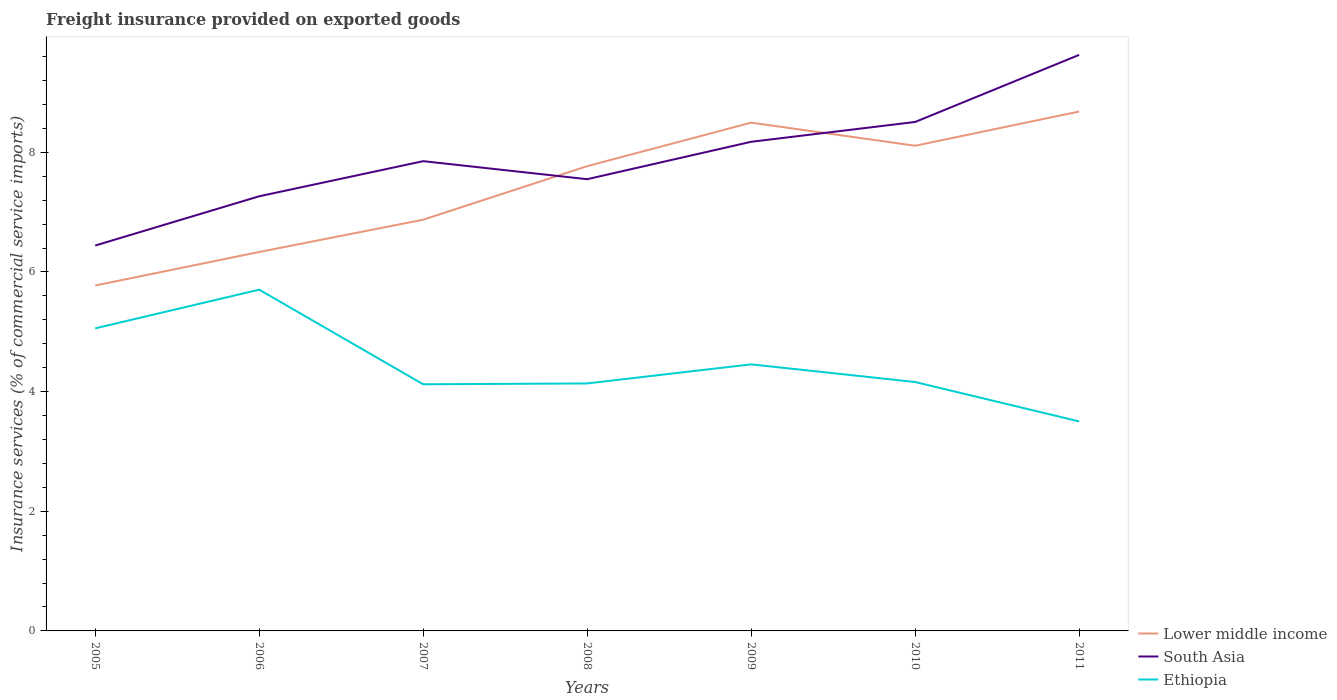How many different coloured lines are there?
Offer a very short reply. 3. Across all years, what is the maximum freight insurance provided on exported goods in South Asia?
Offer a terse response. 6.44. In which year was the freight insurance provided on exported goods in South Asia maximum?
Offer a terse response. 2005. What is the total freight insurance provided on exported goods in South Asia in the graph?
Your answer should be compact. 0.3. What is the difference between the highest and the second highest freight insurance provided on exported goods in South Asia?
Make the answer very short. 3.19. What is the difference between the highest and the lowest freight insurance provided on exported goods in South Asia?
Your answer should be compact. 3. Is the freight insurance provided on exported goods in Ethiopia strictly greater than the freight insurance provided on exported goods in Lower middle income over the years?
Your answer should be compact. Yes. How many years are there in the graph?
Your response must be concise. 7. What is the difference between two consecutive major ticks on the Y-axis?
Offer a terse response. 2. Are the values on the major ticks of Y-axis written in scientific E-notation?
Your response must be concise. No. Does the graph contain any zero values?
Your response must be concise. No. Where does the legend appear in the graph?
Your answer should be very brief. Bottom right. How are the legend labels stacked?
Provide a succinct answer. Vertical. What is the title of the graph?
Your response must be concise. Freight insurance provided on exported goods. What is the label or title of the Y-axis?
Make the answer very short. Insurance services (% of commercial service imports). What is the Insurance services (% of commercial service imports) of Lower middle income in 2005?
Your answer should be compact. 5.77. What is the Insurance services (% of commercial service imports) of South Asia in 2005?
Your answer should be very brief. 6.44. What is the Insurance services (% of commercial service imports) of Ethiopia in 2005?
Offer a very short reply. 5.06. What is the Insurance services (% of commercial service imports) in Lower middle income in 2006?
Your response must be concise. 6.33. What is the Insurance services (% of commercial service imports) in South Asia in 2006?
Offer a very short reply. 7.27. What is the Insurance services (% of commercial service imports) in Ethiopia in 2006?
Offer a terse response. 5.7. What is the Insurance services (% of commercial service imports) of Lower middle income in 2007?
Offer a very short reply. 6.87. What is the Insurance services (% of commercial service imports) in South Asia in 2007?
Your answer should be compact. 7.85. What is the Insurance services (% of commercial service imports) in Ethiopia in 2007?
Keep it short and to the point. 4.12. What is the Insurance services (% of commercial service imports) of Lower middle income in 2008?
Your answer should be compact. 7.77. What is the Insurance services (% of commercial service imports) in South Asia in 2008?
Ensure brevity in your answer.  7.55. What is the Insurance services (% of commercial service imports) in Ethiopia in 2008?
Provide a short and direct response. 4.14. What is the Insurance services (% of commercial service imports) of Lower middle income in 2009?
Offer a terse response. 8.5. What is the Insurance services (% of commercial service imports) in South Asia in 2009?
Keep it short and to the point. 8.18. What is the Insurance services (% of commercial service imports) of Ethiopia in 2009?
Your answer should be very brief. 4.46. What is the Insurance services (% of commercial service imports) of Lower middle income in 2010?
Your answer should be very brief. 8.11. What is the Insurance services (% of commercial service imports) in South Asia in 2010?
Offer a terse response. 8.51. What is the Insurance services (% of commercial service imports) of Ethiopia in 2010?
Provide a short and direct response. 4.16. What is the Insurance services (% of commercial service imports) in Lower middle income in 2011?
Provide a succinct answer. 8.68. What is the Insurance services (% of commercial service imports) in South Asia in 2011?
Make the answer very short. 9.63. What is the Insurance services (% of commercial service imports) of Ethiopia in 2011?
Your answer should be very brief. 3.5. Across all years, what is the maximum Insurance services (% of commercial service imports) of Lower middle income?
Keep it short and to the point. 8.68. Across all years, what is the maximum Insurance services (% of commercial service imports) of South Asia?
Your answer should be very brief. 9.63. Across all years, what is the maximum Insurance services (% of commercial service imports) in Ethiopia?
Make the answer very short. 5.7. Across all years, what is the minimum Insurance services (% of commercial service imports) of Lower middle income?
Offer a terse response. 5.77. Across all years, what is the minimum Insurance services (% of commercial service imports) in South Asia?
Your answer should be very brief. 6.44. Across all years, what is the minimum Insurance services (% of commercial service imports) in Ethiopia?
Provide a succinct answer. 3.5. What is the total Insurance services (% of commercial service imports) of Lower middle income in the graph?
Ensure brevity in your answer.  52.04. What is the total Insurance services (% of commercial service imports) in South Asia in the graph?
Provide a succinct answer. 55.42. What is the total Insurance services (% of commercial service imports) in Ethiopia in the graph?
Make the answer very short. 31.14. What is the difference between the Insurance services (% of commercial service imports) of Lower middle income in 2005 and that in 2006?
Offer a very short reply. -0.56. What is the difference between the Insurance services (% of commercial service imports) of South Asia in 2005 and that in 2006?
Give a very brief answer. -0.82. What is the difference between the Insurance services (% of commercial service imports) of Ethiopia in 2005 and that in 2006?
Offer a very short reply. -0.65. What is the difference between the Insurance services (% of commercial service imports) of Lower middle income in 2005 and that in 2007?
Keep it short and to the point. -1.1. What is the difference between the Insurance services (% of commercial service imports) in South Asia in 2005 and that in 2007?
Make the answer very short. -1.41. What is the difference between the Insurance services (% of commercial service imports) in Ethiopia in 2005 and that in 2007?
Offer a very short reply. 0.94. What is the difference between the Insurance services (% of commercial service imports) of Lower middle income in 2005 and that in 2008?
Keep it short and to the point. -2. What is the difference between the Insurance services (% of commercial service imports) of South Asia in 2005 and that in 2008?
Your answer should be very brief. -1.11. What is the difference between the Insurance services (% of commercial service imports) in Ethiopia in 2005 and that in 2008?
Provide a succinct answer. 0.92. What is the difference between the Insurance services (% of commercial service imports) of Lower middle income in 2005 and that in 2009?
Offer a very short reply. -2.72. What is the difference between the Insurance services (% of commercial service imports) in South Asia in 2005 and that in 2009?
Offer a very short reply. -1.73. What is the difference between the Insurance services (% of commercial service imports) of Ethiopia in 2005 and that in 2009?
Provide a short and direct response. 0.6. What is the difference between the Insurance services (% of commercial service imports) of Lower middle income in 2005 and that in 2010?
Ensure brevity in your answer.  -2.34. What is the difference between the Insurance services (% of commercial service imports) of South Asia in 2005 and that in 2010?
Offer a very short reply. -2.07. What is the difference between the Insurance services (% of commercial service imports) in Ethiopia in 2005 and that in 2010?
Ensure brevity in your answer.  0.9. What is the difference between the Insurance services (% of commercial service imports) of Lower middle income in 2005 and that in 2011?
Make the answer very short. -2.91. What is the difference between the Insurance services (% of commercial service imports) in South Asia in 2005 and that in 2011?
Your answer should be compact. -3.19. What is the difference between the Insurance services (% of commercial service imports) of Ethiopia in 2005 and that in 2011?
Provide a short and direct response. 1.56. What is the difference between the Insurance services (% of commercial service imports) in Lower middle income in 2006 and that in 2007?
Give a very brief answer. -0.54. What is the difference between the Insurance services (% of commercial service imports) in South Asia in 2006 and that in 2007?
Provide a succinct answer. -0.59. What is the difference between the Insurance services (% of commercial service imports) in Ethiopia in 2006 and that in 2007?
Provide a short and direct response. 1.58. What is the difference between the Insurance services (% of commercial service imports) in Lower middle income in 2006 and that in 2008?
Make the answer very short. -1.43. What is the difference between the Insurance services (% of commercial service imports) in South Asia in 2006 and that in 2008?
Offer a terse response. -0.29. What is the difference between the Insurance services (% of commercial service imports) in Ethiopia in 2006 and that in 2008?
Offer a terse response. 1.57. What is the difference between the Insurance services (% of commercial service imports) in Lower middle income in 2006 and that in 2009?
Offer a very short reply. -2.16. What is the difference between the Insurance services (% of commercial service imports) of South Asia in 2006 and that in 2009?
Your answer should be compact. -0.91. What is the difference between the Insurance services (% of commercial service imports) of Ethiopia in 2006 and that in 2009?
Keep it short and to the point. 1.25. What is the difference between the Insurance services (% of commercial service imports) in Lower middle income in 2006 and that in 2010?
Offer a terse response. -1.78. What is the difference between the Insurance services (% of commercial service imports) of South Asia in 2006 and that in 2010?
Offer a terse response. -1.24. What is the difference between the Insurance services (% of commercial service imports) of Ethiopia in 2006 and that in 2010?
Keep it short and to the point. 1.54. What is the difference between the Insurance services (% of commercial service imports) in Lower middle income in 2006 and that in 2011?
Provide a succinct answer. -2.35. What is the difference between the Insurance services (% of commercial service imports) in South Asia in 2006 and that in 2011?
Ensure brevity in your answer.  -2.36. What is the difference between the Insurance services (% of commercial service imports) in Ethiopia in 2006 and that in 2011?
Your response must be concise. 2.2. What is the difference between the Insurance services (% of commercial service imports) in Lower middle income in 2007 and that in 2008?
Offer a terse response. -0.9. What is the difference between the Insurance services (% of commercial service imports) in South Asia in 2007 and that in 2008?
Give a very brief answer. 0.3. What is the difference between the Insurance services (% of commercial service imports) of Ethiopia in 2007 and that in 2008?
Offer a very short reply. -0.01. What is the difference between the Insurance services (% of commercial service imports) in Lower middle income in 2007 and that in 2009?
Your answer should be very brief. -1.62. What is the difference between the Insurance services (% of commercial service imports) in South Asia in 2007 and that in 2009?
Offer a very short reply. -0.32. What is the difference between the Insurance services (% of commercial service imports) in Ethiopia in 2007 and that in 2009?
Provide a succinct answer. -0.33. What is the difference between the Insurance services (% of commercial service imports) in Lower middle income in 2007 and that in 2010?
Ensure brevity in your answer.  -1.24. What is the difference between the Insurance services (% of commercial service imports) in South Asia in 2007 and that in 2010?
Give a very brief answer. -0.66. What is the difference between the Insurance services (% of commercial service imports) of Ethiopia in 2007 and that in 2010?
Offer a very short reply. -0.04. What is the difference between the Insurance services (% of commercial service imports) of Lower middle income in 2007 and that in 2011?
Offer a very short reply. -1.81. What is the difference between the Insurance services (% of commercial service imports) in South Asia in 2007 and that in 2011?
Give a very brief answer. -1.78. What is the difference between the Insurance services (% of commercial service imports) of Ethiopia in 2007 and that in 2011?
Provide a succinct answer. 0.62. What is the difference between the Insurance services (% of commercial service imports) of Lower middle income in 2008 and that in 2009?
Keep it short and to the point. -0.73. What is the difference between the Insurance services (% of commercial service imports) in South Asia in 2008 and that in 2009?
Your answer should be compact. -0.63. What is the difference between the Insurance services (% of commercial service imports) of Ethiopia in 2008 and that in 2009?
Your answer should be compact. -0.32. What is the difference between the Insurance services (% of commercial service imports) of Lower middle income in 2008 and that in 2010?
Your response must be concise. -0.34. What is the difference between the Insurance services (% of commercial service imports) of South Asia in 2008 and that in 2010?
Ensure brevity in your answer.  -0.96. What is the difference between the Insurance services (% of commercial service imports) in Ethiopia in 2008 and that in 2010?
Provide a short and direct response. -0.02. What is the difference between the Insurance services (% of commercial service imports) in Lower middle income in 2008 and that in 2011?
Provide a short and direct response. -0.91. What is the difference between the Insurance services (% of commercial service imports) in South Asia in 2008 and that in 2011?
Your response must be concise. -2.08. What is the difference between the Insurance services (% of commercial service imports) in Ethiopia in 2008 and that in 2011?
Your answer should be very brief. 0.63. What is the difference between the Insurance services (% of commercial service imports) of Lower middle income in 2009 and that in 2010?
Offer a very short reply. 0.39. What is the difference between the Insurance services (% of commercial service imports) of South Asia in 2009 and that in 2010?
Ensure brevity in your answer.  -0.33. What is the difference between the Insurance services (% of commercial service imports) of Ethiopia in 2009 and that in 2010?
Your answer should be compact. 0.3. What is the difference between the Insurance services (% of commercial service imports) of Lower middle income in 2009 and that in 2011?
Give a very brief answer. -0.19. What is the difference between the Insurance services (% of commercial service imports) in South Asia in 2009 and that in 2011?
Keep it short and to the point. -1.45. What is the difference between the Insurance services (% of commercial service imports) in Ethiopia in 2009 and that in 2011?
Make the answer very short. 0.95. What is the difference between the Insurance services (% of commercial service imports) in Lower middle income in 2010 and that in 2011?
Your answer should be very brief. -0.57. What is the difference between the Insurance services (% of commercial service imports) in South Asia in 2010 and that in 2011?
Provide a succinct answer. -1.12. What is the difference between the Insurance services (% of commercial service imports) of Ethiopia in 2010 and that in 2011?
Offer a terse response. 0.66. What is the difference between the Insurance services (% of commercial service imports) in Lower middle income in 2005 and the Insurance services (% of commercial service imports) in South Asia in 2006?
Give a very brief answer. -1.49. What is the difference between the Insurance services (% of commercial service imports) in Lower middle income in 2005 and the Insurance services (% of commercial service imports) in Ethiopia in 2006?
Keep it short and to the point. 0.07. What is the difference between the Insurance services (% of commercial service imports) in South Asia in 2005 and the Insurance services (% of commercial service imports) in Ethiopia in 2006?
Ensure brevity in your answer.  0.74. What is the difference between the Insurance services (% of commercial service imports) of Lower middle income in 2005 and the Insurance services (% of commercial service imports) of South Asia in 2007?
Keep it short and to the point. -2.08. What is the difference between the Insurance services (% of commercial service imports) in Lower middle income in 2005 and the Insurance services (% of commercial service imports) in Ethiopia in 2007?
Provide a succinct answer. 1.65. What is the difference between the Insurance services (% of commercial service imports) of South Asia in 2005 and the Insurance services (% of commercial service imports) of Ethiopia in 2007?
Your response must be concise. 2.32. What is the difference between the Insurance services (% of commercial service imports) of Lower middle income in 2005 and the Insurance services (% of commercial service imports) of South Asia in 2008?
Offer a terse response. -1.78. What is the difference between the Insurance services (% of commercial service imports) in Lower middle income in 2005 and the Insurance services (% of commercial service imports) in Ethiopia in 2008?
Your answer should be very brief. 1.64. What is the difference between the Insurance services (% of commercial service imports) in South Asia in 2005 and the Insurance services (% of commercial service imports) in Ethiopia in 2008?
Give a very brief answer. 2.3. What is the difference between the Insurance services (% of commercial service imports) of Lower middle income in 2005 and the Insurance services (% of commercial service imports) of South Asia in 2009?
Offer a very short reply. -2.4. What is the difference between the Insurance services (% of commercial service imports) of Lower middle income in 2005 and the Insurance services (% of commercial service imports) of Ethiopia in 2009?
Your response must be concise. 1.32. What is the difference between the Insurance services (% of commercial service imports) of South Asia in 2005 and the Insurance services (% of commercial service imports) of Ethiopia in 2009?
Keep it short and to the point. 1.99. What is the difference between the Insurance services (% of commercial service imports) in Lower middle income in 2005 and the Insurance services (% of commercial service imports) in South Asia in 2010?
Ensure brevity in your answer.  -2.73. What is the difference between the Insurance services (% of commercial service imports) in Lower middle income in 2005 and the Insurance services (% of commercial service imports) in Ethiopia in 2010?
Offer a terse response. 1.61. What is the difference between the Insurance services (% of commercial service imports) of South Asia in 2005 and the Insurance services (% of commercial service imports) of Ethiopia in 2010?
Keep it short and to the point. 2.28. What is the difference between the Insurance services (% of commercial service imports) of Lower middle income in 2005 and the Insurance services (% of commercial service imports) of South Asia in 2011?
Give a very brief answer. -3.85. What is the difference between the Insurance services (% of commercial service imports) in Lower middle income in 2005 and the Insurance services (% of commercial service imports) in Ethiopia in 2011?
Provide a succinct answer. 2.27. What is the difference between the Insurance services (% of commercial service imports) in South Asia in 2005 and the Insurance services (% of commercial service imports) in Ethiopia in 2011?
Make the answer very short. 2.94. What is the difference between the Insurance services (% of commercial service imports) of Lower middle income in 2006 and the Insurance services (% of commercial service imports) of South Asia in 2007?
Offer a very short reply. -1.52. What is the difference between the Insurance services (% of commercial service imports) in Lower middle income in 2006 and the Insurance services (% of commercial service imports) in Ethiopia in 2007?
Give a very brief answer. 2.21. What is the difference between the Insurance services (% of commercial service imports) in South Asia in 2006 and the Insurance services (% of commercial service imports) in Ethiopia in 2007?
Offer a terse response. 3.14. What is the difference between the Insurance services (% of commercial service imports) of Lower middle income in 2006 and the Insurance services (% of commercial service imports) of South Asia in 2008?
Provide a short and direct response. -1.22. What is the difference between the Insurance services (% of commercial service imports) in Lower middle income in 2006 and the Insurance services (% of commercial service imports) in Ethiopia in 2008?
Provide a short and direct response. 2.2. What is the difference between the Insurance services (% of commercial service imports) in South Asia in 2006 and the Insurance services (% of commercial service imports) in Ethiopia in 2008?
Your answer should be compact. 3.13. What is the difference between the Insurance services (% of commercial service imports) of Lower middle income in 2006 and the Insurance services (% of commercial service imports) of South Asia in 2009?
Offer a terse response. -1.84. What is the difference between the Insurance services (% of commercial service imports) of Lower middle income in 2006 and the Insurance services (% of commercial service imports) of Ethiopia in 2009?
Give a very brief answer. 1.88. What is the difference between the Insurance services (% of commercial service imports) in South Asia in 2006 and the Insurance services (% of commercial service imports) in Ethiopia in 2009?
Provide a short and direct response. 2.81. What is the difference between the Insurance services (% of commercial service imports) in Lower middle income in 2006 and the Insurance services (% of commercial service imports) in South Asia in 2010?
Your response must be concise. -2.17. What is the difference between the Insurance services (% of commercial service imports) in Lower middle income in 2006 and the Insurance services (% of commercial service imports) in Ethiopia in 2010?
Your response must be concise. 2.17. What is the difference between the Insurance services (% of commercial service imports) in South Asia in 2006 and the Insurance services (% of commercial service imports) in Ethiopia in 2010?
Ensure brevity in your answer.  3.11. What is the difference between the Insurance services (% of commercial service imports) of Lower middle income in 2006 and the Insurance services (% of commercial service imports) of South Asia in 2011?
Ensure brevity in your answer.  -3.29. What is the difference between the Insurance services (% of commercial service imports) in Lower middle income in 2006 and the Insurance services (% of commercial service imports) in Ethiopia in 2011?
Give a very brief answer. 2.83. What is the difference between the Insurance services (% of commercial service imports) of South Asia in 2006 and the Insurance services (% of commercial service imports) of Ethiopia in 2011?
Ensure brevity in your answer.  3.76. What is the difference between the Insurance services (% of commercial service imports) of Lower middle income in 2007 and the Insurance services (% of commercial service imports) of South Asia in 2008?
Offer a terse response. -0.68. What is the difference between the Insurance services (% of commercial service imports) of Lower middle income in 2007 and the Insurance services (% of commercial service imports) of Ethiopia in 2008?
Offer a terse response. 2.74. What is the difference between the Insurance services (% of commercial service imports) of South Asia in 2007 and the Insurance services (% of commercial service imports) of Ethiopia in 2008?
Offer a terse response. 3.72. What is the difference between the Insurance services (% of commercial service imports) in Lower middle income in 2007 and the Insurance services (% of commercial service imports) in South Asia in 2009?
Provide a short and direct response. -1.3. What is the difference between the Insurance services (% of commercial service imports) of Lower middle income in 2007 and the Insurance services (% of commercial service imports) of Ethiopia in 2009?
Make the answer very short. 2.42. What is the difference between the Insurance services (% of commercial service imports) in South Asia in 2007 and the Insurance services (% of commercial service imports) in Ethiopia in 2009?
Provide a succinct answer. 3.4. What is the difference between the Insurance services (% of commercial service imports) of Lower middle income in 2007 and the Insurance services (% of commercial service imports) of South Asia in 2010?
Your answer should be compact. -1.63. What is the difference between the Insurance services (% of commercial service imports) of Lower middle income in 2007 and the Insurance services (% of commercial service imports) of Ethiopia in 2010?
Your response must be concise. 2.71. What is the difference between the Insurance services (% of commercial service imports) of South Asia in 2007 and the Insurance services (% of commercial service imports) of Ethiopia in 2010?
Provide a succinct answer. 3.69. What is the difference between the Insurance services (% of commercial service imports) of Lower middle income in 2007 and the Insurance services (% of commercial service imports) of South Asia in 2011?
Provide a short and direct response. -2.75. What is the difference between the Insurance services (% of commercial service imports) in Lower middle income in 2007 and the Insurance services (% of commercial service imports) in Ethiopia in 2011?
Your answer should be compact. 3.37. What is the difference between the Insurance services (% of commercial service imports) of South Asia in 2007 and the Insurance services (% of commercial service imports) of Ethiopia in 2011?
Provide a short and direct response. 4.35. What is the difference between the Insurance services (% of commercial service imports) of Lower middle income in 2008 and the Insurance services (% of commercial service imports) of South Asia in 2009?
Your answer should be very brief. -0.41. What is the difference between the Insurance services (% of commercial service imports) of Lower middle income in 2008 and the Insurance services (% of commercial service imports) of Ethiopia in 2009?
Offer a very short reply. 3.31. What is the difference between the Insurance services (% of commercial service imports) in South Asia in 2008 and the Insurance services (% of commercial service imports) in Ethiopia in 2009?
Keep it short and to the point. 3.1. What is the difference between the Insurance services (% of commercial service imports) in Lower middle income in 2008 and the Insurance services (% of commercial service imports) in South Asia in 2010?
Make the answer very short. -0.74. What is the difference between the Insurance services (% of commercial service imports) in Lower middle income in 2008 and the Insurance services (% of commercial service imports) in Ethiopia in 2010?
Make the answer very short. 3.61. What is the difference between the Insurance services (% of commercial service imports) of South Asia in 2008 and the Insurance services (% of commercial service imports) of Ethiopia in 2010?
Your answer should be compact. 3.39. What is the difference between the Insurance services (% of commercial service imports) in Lower middle income in 2008 and the Insurance services (% of commercial service imports) in South Asia in 2011?
Your answer should be very brief. -1.86. What is the difference between the Insurance services (% of commercial service imports) of Lower middle income in 2008 and the Insurance services (% of commercial service imports) of Ethiopia in 2011?
Give a very brief answer. 4.27. What is the difference between the Insurance services (% of commercial service imports) in South Asia in 2008 and the Insurance services (% of commercial service imports) in Ethiopia in 2011?
Your response must be concise. 4.05. What is the difference between the Insurance services (% of commercial service imports) in Lower middle income in 2009 and the Insurance services (% of commercial service imports) in South Asia in 2010?
Your answer should be compact. -0.01. What is the difference between the Insurance services (% of commercial service imports) of Lower middle income in 2009 and the Insurance services (% of commercial service imports) of Ethiopia in 2010?
Provide a succinct answer. 4.34. What is the difference between the Insurance services (% of commercial service imports) of South Asia in 2009 and the Insurance services (% of commercial service imports) of Ethiopia in 2010?
Offer a terse response. 4.02. What is the difference between the Insurance services (% of commercial service imports) in Lower middle income in 2009 and the Insurance services (% of commercial service imports) in South Asia in 2011?
Your response must be concise. -1.13. What is the difference between the Insurance services (% of commercial service imports) of Lower middle income in 2009 and the Insurance services (% of commercial service imports) of Ethiopia in 2011?
Offer a very short reply. 4.99. What is the difference between the Insurance services (% of commercial service imports) in South Asia in 2009 and the Insurance services (% of commercial service imports) in Ethiopia in 2011?
Your answer should be very brief. 4.67. What is the difference between the Insurance services (% of commercial service imports) of Lower middle income in 2010 and the Insurance services (% of commercial service imports) of South Asia in 2011?
Offer a terse response. -1.52. What is the difference between the Insurance services (% of commercial service imports) in Lower middle income in 2010 and the Insurance services (% of commercial service imports) in Ethiopia in 2011?
Ensure brevity in your answer.  4.61. What is the difference between the Insurance services (% of commercial service imports) of South Asia in 2010 and the Insurance services (% of commercial service imports) of Ethiopia in 2011?
Ensure brevity in your answer.  5.01. What is the average Insurance services (% of commercial service imports) of Lower middle income per year?
Your answer should be very brief. 7.43. What is the average Insurance services (% of commercial service imports) of South Asia per year?
Your answer should be very brief. 7.92. What is the average Insurance services (% of commercial service imports) of Ethiopia per year?
Offer a very short reply. 4.45. In the year 2005, what is the difference between the Insurance services (% of commercial service imports) of Lower middle income and Insurance services (% of commercial service imports) of South Asia?
Keep it short and to the point. -0.67. In the year 2005, what is the difference between the Insurance services (% of commercial service imports) in Lower middle income and Insurance services (% of commercial service imports) in Ethiopia?
Make the answer very short. 0.72. In the year 2005, what is the difference between the Insurance services (% of commercial service imports) in South Asia and Insurance services (% of commercial service imports) in Ethiopia?
Your response must be concise. 1.38. In the year 2006, what is the difference between the Insurance services (% of commercial service imports) in Lower middle income and Insurance services (% of commercial service imports) in South Asia?
Ensure brevity in your answer.  -0.93. In the year 2006, what is the difference between the Insurance services (% of commercial service imports) in Lower middle income and Insurance services (% of commercial service imports) in Ethiopia?
Your answer should be very brief. 0.63. In the year 2006, what is the difference between the Insurance services (% of commercial service imports) of South Asia and Insurance services (% of commercial service imports) of Ethiopia?
Give a very brief answer. 1.56. In the year 2007, what is the difference between the Insurance services (% of commercial service imports) of Lower middle income and Insurance services (% of commercial service imports) of South Asia?
Provide a succinct answer. -0.98. In the year 2007, what is the difference between the Insurance services (% of commercial service imports) in Lower middle income and Insurance services (% of commercial service imports) in Ethiopia?
Provide a succinct answer. 2.75. In the year 2007, what is the difference between the Insurance services (% of commercial service imports) in South Asia and Insurance services (% of commercial service imports) in Ethiopia?
Your answer should be compact. 3.73. In the year 2008, what is the difference between the Insurance services (% of commercial service imports) in Lower middle income and Insurance services (% of commercial service imports) in South Asia?
Provide a succinct answer. 0.22. In the year 2008, what is the difference between the Insurance services (% of commercial service imports) of Lower middle income and Insurance services (% of commercial service imports) of Ethiopia?
Make the answer very short. 3.63. In the year 2008, what is the difference between the Insurance services (% of commercial service imports) in South Asia and Insurance services (% of commercial service imports) in Ethiopia?
Make the answer very short. 3.41. In the year 2009, what is the difference between the Insurance services (% of commercial service imports) of Lower middle income and Insurance services (% of commercial service imports) of South Asia?
Provide a short and direct response. 0.32. In the year 2009, what is the difference between the Insurance services (% of commercial service imports) in Lower middle income and Insurance services (% of commercial service imports) in Ethiopia?
Offer a very short reply. 4.04. In the year 2009, what is the difference between the Insurance services (% of commercial service imports) in South Asia and Insurance services (% of commercial service imports) in Ethiopia?
Keep it short and to the point. 3.72. In the year 2010, what is the difference between the Insurance services (% of commercial service imports) in Lower middle income and Insurance services (% of commercial service imports) in South Asia?
Keep it short and to the point. -0.4. In the year 2010, what is the difference between the Insurance services (% of commercial service imports) of Lower middle income and Insurance services (% of commercial service imports) of Ethiopia?
Keep it short and to the point. 3.95. In the year 2010, what is the difference between the Insurance services (% of commercial service imports) in South Asia and Insurance services (% of commercial service imports) in Ethiopia?
Your answer should be compact. 4.35. In the year 2011, what is the difference between the Insurance services (% of commercial service imports) of Lower middle income and Insurance services (% of commercial service imports) of South Asia?
Ensure brevity in your answer.  -0.95. In the year 2011, what is the difference between the Insurance services (% of commercial service imports) of Lower middle income and Insurance services (% of commercial service imports) of Ethiopia?
Keep it short and to the point. 5.18. In the year 2011, what is the difference between the Insurance services (% of commercial service imports) of South Asia and Insurance services (% of commercial service imports) of Ethiopia?
Offer a very short reply. 6.13. What is the ratio of the Insurance services (% of commercial service imports) in Lower middle income in 2005 to that in 2006?
Ensure brevity in your answer.  0.91. What is the ratio of the Insurance services (% of commercial service imports) of South Asia in 2005 to that in 2006?
Your answer should be compact. 0.89. What is the ratio of the Insurance services (% of commercial service imports) in Ethiopia in 2005 to that in 2006?
Your response must be concise. 0.89. What is the ratio of the Insurance services (% of commercial service imports) of Lower middle income in 2005 to that in 2007?
Offer a terse response. 0.84. What is the ratio of the Insurance services (% of commercial service imports) in South Asia in 2005 to that in 2007?
Ensure brevity in your answer.  0.82. What is the ratio of the Insurance services (% of commercial service imports) in Ethiopia in 2005 to that in 2007?
Provide a succinct answer. 1.23. What is the ratio of the Insurance services (% of commercial service imports) in Lower middle income in 2005 to that in 2008?
Offer a very short reply. 0.74. What is the ratio of the Insurance services (% of commercial service imports) in South Asia in 2005 to that in 2008?
Offer a very short reply. 0.85. What is the ratio of the Insurance services (% of commercial service imports) of Ethiopia in 2005 to that in 2008?
Provide a succinct answer. 1.22. What is the ratio of the Insurance services (% of commercial service imports) in Lower middle income in 2005 to that in 2009?
Keep it short and to the point. 0.68. What is the ratio of the Insurance services (% of commercial service imports) in South Asia in 2005 to that in 2009?
Ensure brevity in your answer.  0.79. What is the ratio of the Insurance services (% of commercial service imports) in Ethiopia in 2005 to that in 2009?
Offer a terse response. 1.14. What is the ratio of the Insurance services (% of commercial service imports) in Lower middle income in 2005 to that in 2010?
Keep it short and to the point. 0.71. What is the ratio of the Insurance services (% of commercial service imports) of South Asia in 2005 to that in 2010?
Offer a very short reply. 0.76. What is the ratio of the Insurance services (% of commercial service imports) of Ethiopia in 2005 to that in 2010?
Provide a succinct answer. 1.22. What is the ratio of the Insurance services (% of commercial service imports) of Lower middle income in 2005 to that in 2011?
Provide a succinct answer. 0.67. What is the ratio of the Insurance services (% of commercial service imports) in South Asia in 2005 to that in 2011?
Offer a very short reply. 0.67. What is the ratio of the Insurance services (% of commercial service imports) in Ethiopia in 2005 to that in 2011?
Give a very brief answer. 1.44. What is the ratio of the Insurance services (% of commercial service imports) of Lower middle income in 2006 to that in 2007?
Your answer should be compact. 0.92. What is the ratio of the Insurance services (% of commercial service imports) in South Asia in 2006 to that in 2007?
Provide a succinct answer. 0.93. What is the ratio of the Insurance services (% of commercial service imports) of Ethiopia in 2006 to that in 2007?
Ensure brevity in your answer.  1.38. What is the ratio of the Insurance services (% of commercial service imports) of Lower middle income in 2006 to that in 2008?
Provide a short and direct response. 0.82. What is the ratio of the Insurance services (% of commercial service imports) in South Asia in 2006 to that in 2008?
Your answer should be compact. 0.96. What is the ratio of the Insurance services (% of commercial service imports) of Ethiopia in 2006 to that in 2008?
Make the answer very short. 1.38. What is the ratio of the Insurance services (% of commercial service imports) of Lower middle income in 2006 to that in 2009?
Give a very brief answer. 0.75. What is the ratio of the Insurance services (% of commercial service imports) in South Asia in 2006 to that in 2009?
Offer a very short reply. 0.89. What is the ratio of the Insurance services (% of commercial service imports) of Ethiopia in 2006 to that in 2009?
Provide a succinct answer. 1.28. What is the ratio of the Insurance services (% of commercial service imports) in Lower middle income in 2006 to that in 2010?
Ensure brevity in your answer.  0.78. What is the ratio of the Insurance services (% of commercial service imports) of South Asia in 2006 to that in 2010?
Offer a very short reply. 0.85. What is the ratio of the Insurance services (% of commercial service imports) of Ethiopia in 2006 to that in 2010?
Provide a short and direct response. 1.37. What is the ratio of the Insurance services (% of commercial service imports) of Lower middle income in 2006 to that in 2011?
Give a very brief answer. 0.73. What is the ratio of the Insurance services (% of commercial service imports) of South Asia in 2006 to that in 2011?
Offer a terse response. 0.75. What is the ratio of the Insurance services (% of commercial service imports) in Ethiopia in 2006 to that in 2011?
Ensure brevity in your answer.  1.63. What is the ratio of the Insurance services (% of commercial service imports) of Lower middle income in 2007 to that in 2008?
Provide a succinct answer. 0.88. What is the ratio of the Insurance services (% of commercial service imports) of South Asia in 2007 to that in 2008?
Provide a succinct answer. 1.04. What is the ratio of the Insurance services (% of commercial service imports) in Lower middle income in 2007 to that in 2009?
Give a very brief answer. 0.81. What is the ratio of the Insurance services (% of commercial service imports) of South Asia in 2007 to that in 2009?
Ensure brevity in your answer.  0.96. What is the ratio of the Insurance services (% of commercial service imports) in Ethiopia in 2007 to that in 2009?
Offer a very short reply. 0.93. What is the ratio of the Insurance services (% of commercial service imports) in Lower middle income in 2007 to that in 2010?
Provide a succinct answer. 0.85. What is the ratio of the Insurance services (% of commercial service imports) in South Asia in 2007 to that in 2010?
Provide a succinct answer. 0.92. What is the ratio of the Insurance services (% of commercial service imports) of Ethiopia in 2007 to that in 2010?
Give a very brief answer. 0.99. What is the ratio of the Insurance services (% of commercial service imports) of Lower middle income in 2007 to that in 2011?
Provide a short and direct response. 0.79. What is the ratio of the Insurance services (% of commercial service imports) in South Asia in 2007 to that in 2011?
Give a very brief answer. 0.82. What is the ratio of the Insurance services (% of commercial service imports) of Ethiopia in 2007 to that in 2011?
Your answer should be very brief. 1.18. What is the ratio of the Insurance services (% of commercial service imports) in Lower middle income in 2008 to that in 2009?
Offer a very short reply. 0.91. What is the ratio of the Insurance services (% of commercial service imports) of South Asia in 2008 to that in 2009?
Give a very brief answer. 0.92. What is the ratio of the Insurance services (% of commercial service imports) in Ethiopia in 2008 to that in 2009?
Provide a succinct answer. 0.93. What is the ratio of the Insurance services (% of commercial service imports) of Lower middle income in 2008 to that in 2010?
Your answer should be compact. 0.96. What is the ratio of the Insurance services (% of commercial service imports) of South Asia in 2008 to that in 2010?
Offer a terse response. 0.89. What is the ratio of the Insurance services (% of commercial service imports) in Ethiopia in 2008 to that in 2010?
Keep it short and to the point. 0.99. What is the ratio of the Insurance services (% of commercial service imports) of Lower middle income in 2008 to that in 2011?
Offer a very short reply. 0.89. What is the ratio of the Insurance services (% of commercial service imports) of South Asia in 2008 to that in 2011?
Ensure brevity in your answer.  0.78. What is the ratio of the Insurance services (% of commercial service imports) in Ethiopia in 2008 to that in 2011?
Provide a short and direct response. 1.18. What is the ratio of the Insurance services (% of commercial service imports) in Lower middle income in 2009 to that in 2010?
Your answer should be very brief. 1.05. What is the ratio of the Insurance services (% of commercial service imports) in South Asia in 2009 to that in 2010?
Make the answer very short. 0.96. What is the ratio of the Insurance services (% of commercial service imports) in Ethiopia in 2009 to that in 2010?
Ensure brevity in your answer.  1.07. What is the ratio of the Insurance services (% of commercial service imports) of Lower middle income in 2009 to that in 2011?
Give a very brief answer. 0.98. What is the ratio of the Insurance services (% of commercial service imports) of South Asia in 2009 to that in 2011?
Offer a very short reply. 0.85. What is the ratio of the Insurance services (% of commercial service imports) of Ethiopia in 2009 to that in 2011?
Ensure brevity in your answer.  1.27. What is the ratio of the Insurance services (% of commercial service imports) in Lower middle income in 2010 to that in 2011?
Offer a very short reply. 0.93. What is the ratio of the Insurance services (% of commercial service imports) of South Asia in 2010 to that in 2011?
Offer a terse response. 0.88. What is the ratio of the Insurance services (% of commercial service imports) of Ethiopia in 2010 to that in 2011?
Provide a short and direct response. 1.19. What is the difference between the highest and the second highest Insurance services (% of commercial service imports) of Lower middle income?
Provide a succinct answer. 0.19. What is the difference between the highest and the second highest Insurance services (% of commercial service imports) in South Asia?
Offer a terse response. 1.12. What is the difference between the highest and the second highest Insurance services (% of commercial service imports) of Ethiopia?
Your answer should be compact. 0.65. What is the difference between the highest and the lowest Insurance services (% of commercial service imports) of Lower middle income?
Provide a short and direct response. 2.91. What is the difference between the highest and the lowest Insurance services (% of commercial service imports) of South Asia?
Keep it short and to the point. 3.19. What is the difference between the highest and the lowest Insurance services (% of commercial service imports) of Ethiopia?
Provide a succinct answer. 2.2. 